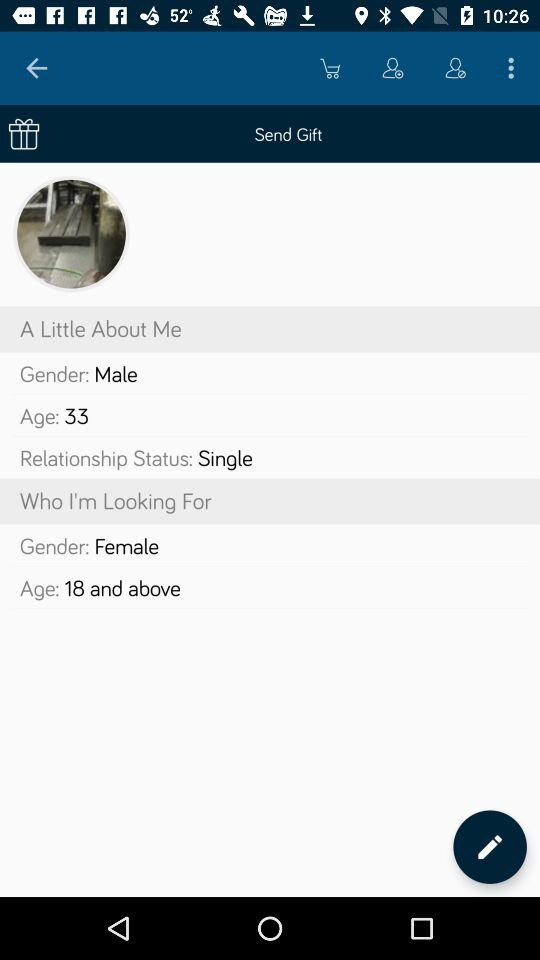What age is the person looking for? The person is looking for people aged 18 and above. 